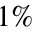Convert formula to latex. <formula><loc_0><loc_0><loc_500><loc_500>1 \%</formula> 